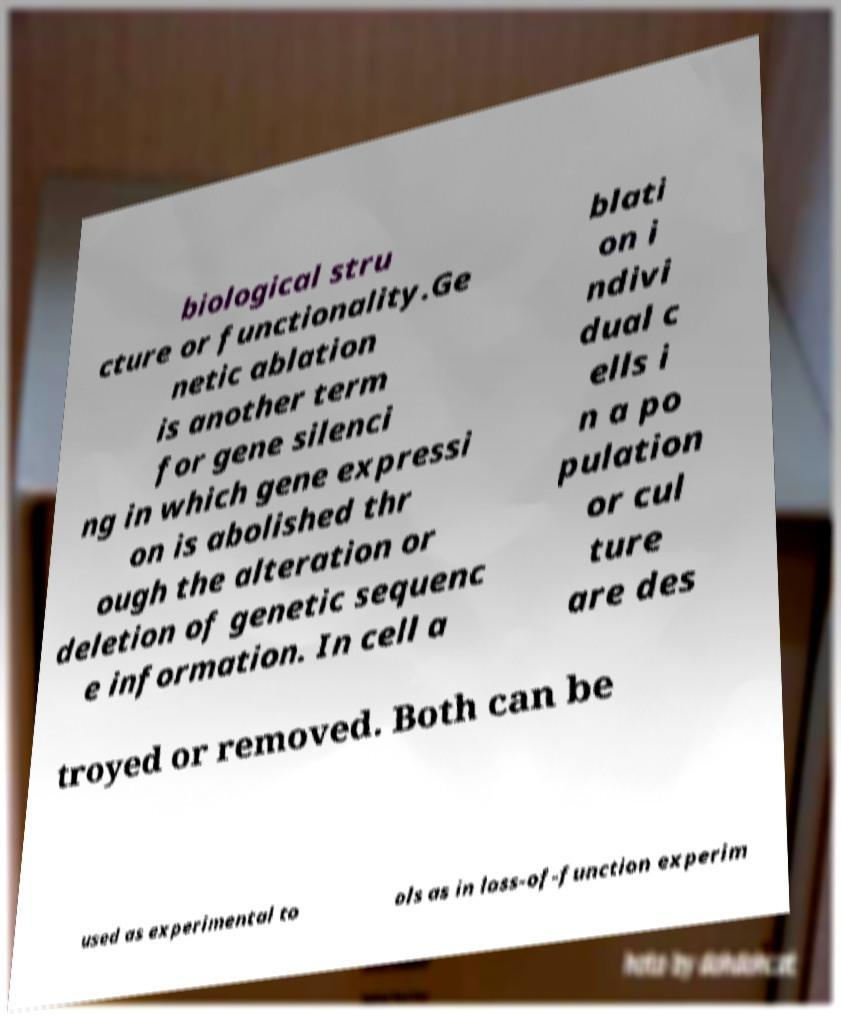Could you assist in decoding the text presented in this image and type it out clearly? biological stru cture or functionality.Ge netic ablation is another term for gene silenci ng in which gene expressi on is abolished thr ough the alteration or deletion of genetic sequenc e information. In cell a blati on i ndivi dual c ells i n a po pulation or cul ture are des troyed or removed. Both can be used as experimental to ols as in loss-of-function experim 